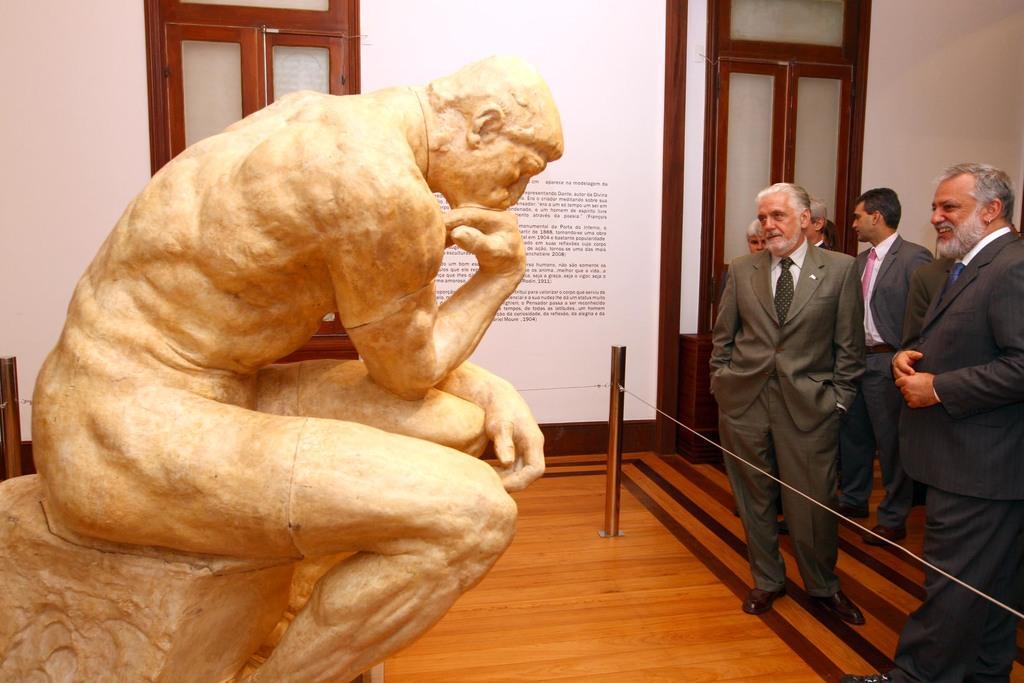Can you describe this image briefly? On the left side, there is a statue of a nude person, sitting on a rock. On the right side, there are persons in suits, standing. One of them is smiling. In front of them, there is a fence. In the background, there are texts on the white color wall. Beside them, there is a window. 